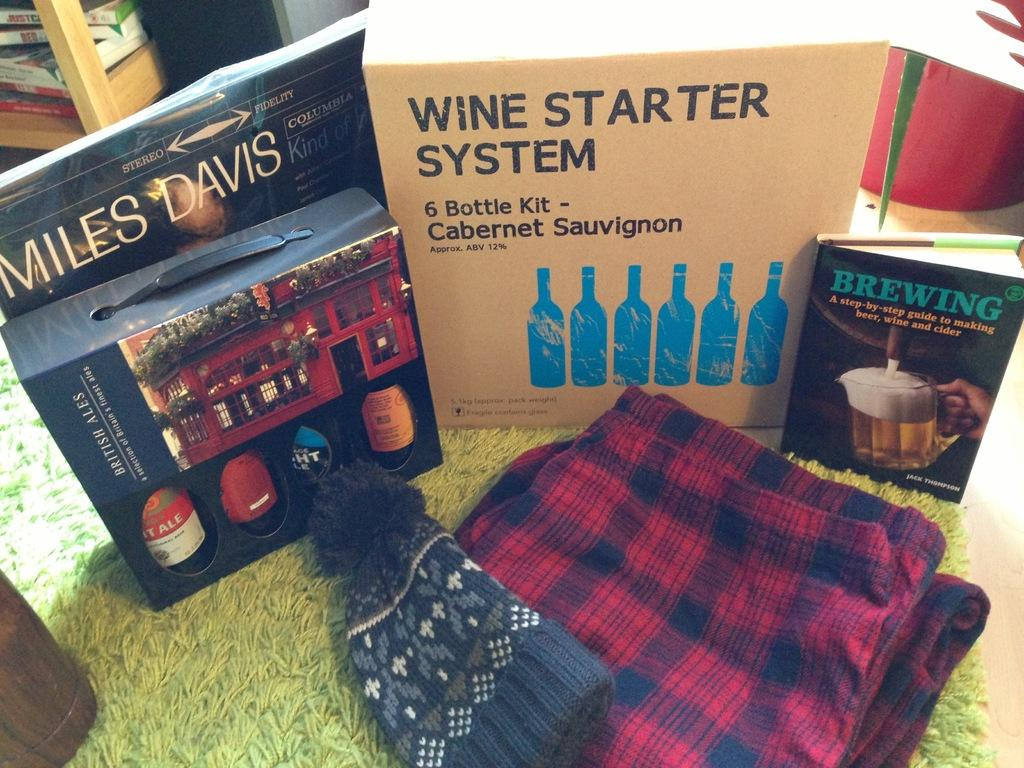<image>
Provide a brief description of the given image. A box with a Wine Starter System sits on a table with other beer and wine items 